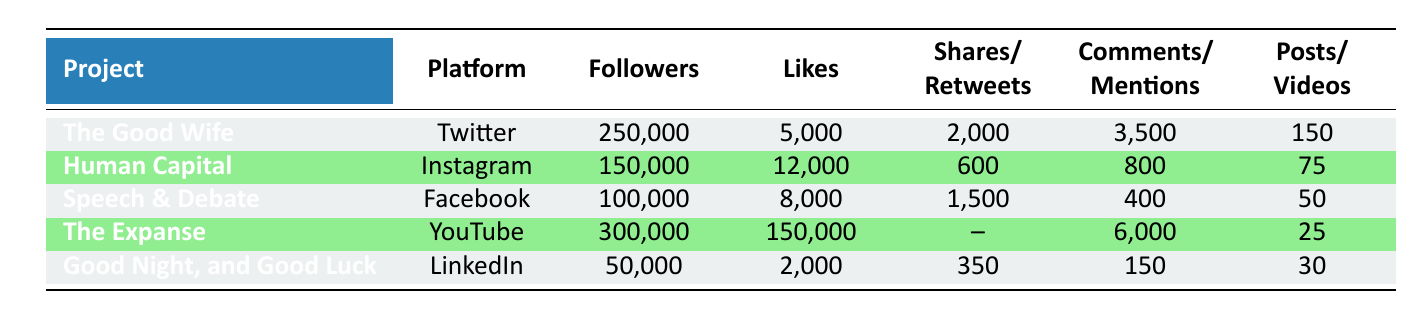What is the total number of followers across all projects? To find the total number of followers, we sum the followers for each project: 250,000 (The Good Wife) + 150,000 (Human Capital) + 100,000 (Speech & Debate) + 300,000 (The Expanse) + 50,000 (Good Night, and Good Luck) = 850,000.
Answer: 850,000 Which project has the highest number of likes? The project with the highest number of likes is The Expanse with 150,000 likes. We can see all like counts in the Likes column and identify The Expanse as the largest value.
Answer: The Expanse Is the number of shares for Human Capital greater than for Speech & Debate? The number of shares for Human Capital is 600, while for Speech & Debate it is 1,500. Since 600 is not greater than 1,500, the answer is no.
Answer: No What is the average number of posts or videos per project? We have the following post counts: 150 (The Good Wife), 75 (Human Capital), 50 (Speech & Debate), 25 (The Expanse), and 30 (Good Night, and Good Luck). Adding these gives a total of 330 posts/videos. There are 5 projects, so we divide: 330/5 = 66.
Answer: 66 How many total likes does The Good Wife and Good Night, and Good Luck receive combined? The Good Wife has 5,000 likes and Good Night, and Good Luck has 2,000 likes. Adding these gives: 5,000 + 2,000 = 7,000.
Answer: 7,000 Does The Expanse have more likes than both The Good Wife and Human Capital combined? The Expanse has 150,000 likes. The Good Wife has 5,000 and Human Capital has 12,000, giving a combined total of 5,000 + 12,000 = 17,000. Since 150,000 is greater than 17,000, the answer is yes.
Answer: Yes What is the difference in the number of followers between The Expanse and Good Night, and Good Luck? The Expanse has 300,000 followers and Good Night, and Good Luck has 50,000 followers. The difference is calculated by subtracting the lower from the higher: 300,000 - 50,000 = 250,000.
Answer: 250,000 Which platform has the least number of followers for a project? The platform with the least number of followers is LinkedIn for the project Good Night, and Good Luck, which has 50,000 followers. Looking at the Followers column confirms this is the smallest value.
Answer: LinkedIn 